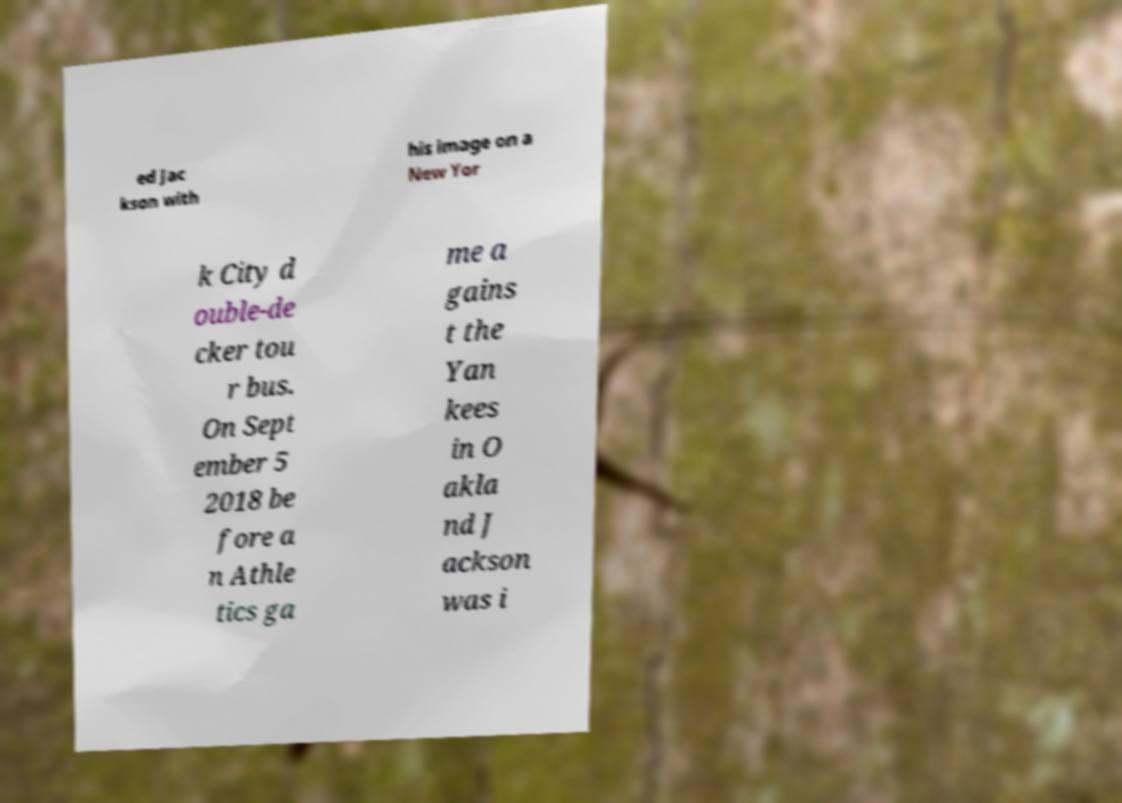What messages or text are displayed in this image? I need them in a readable, typed format. ed Jac kson with his image on a New Yor k City d ouble-de cker tou r bus. On Sept ember 5 2018 be fore a n Athle tics ga me a gains t the Yan kees in O akla nd J ackson was i 